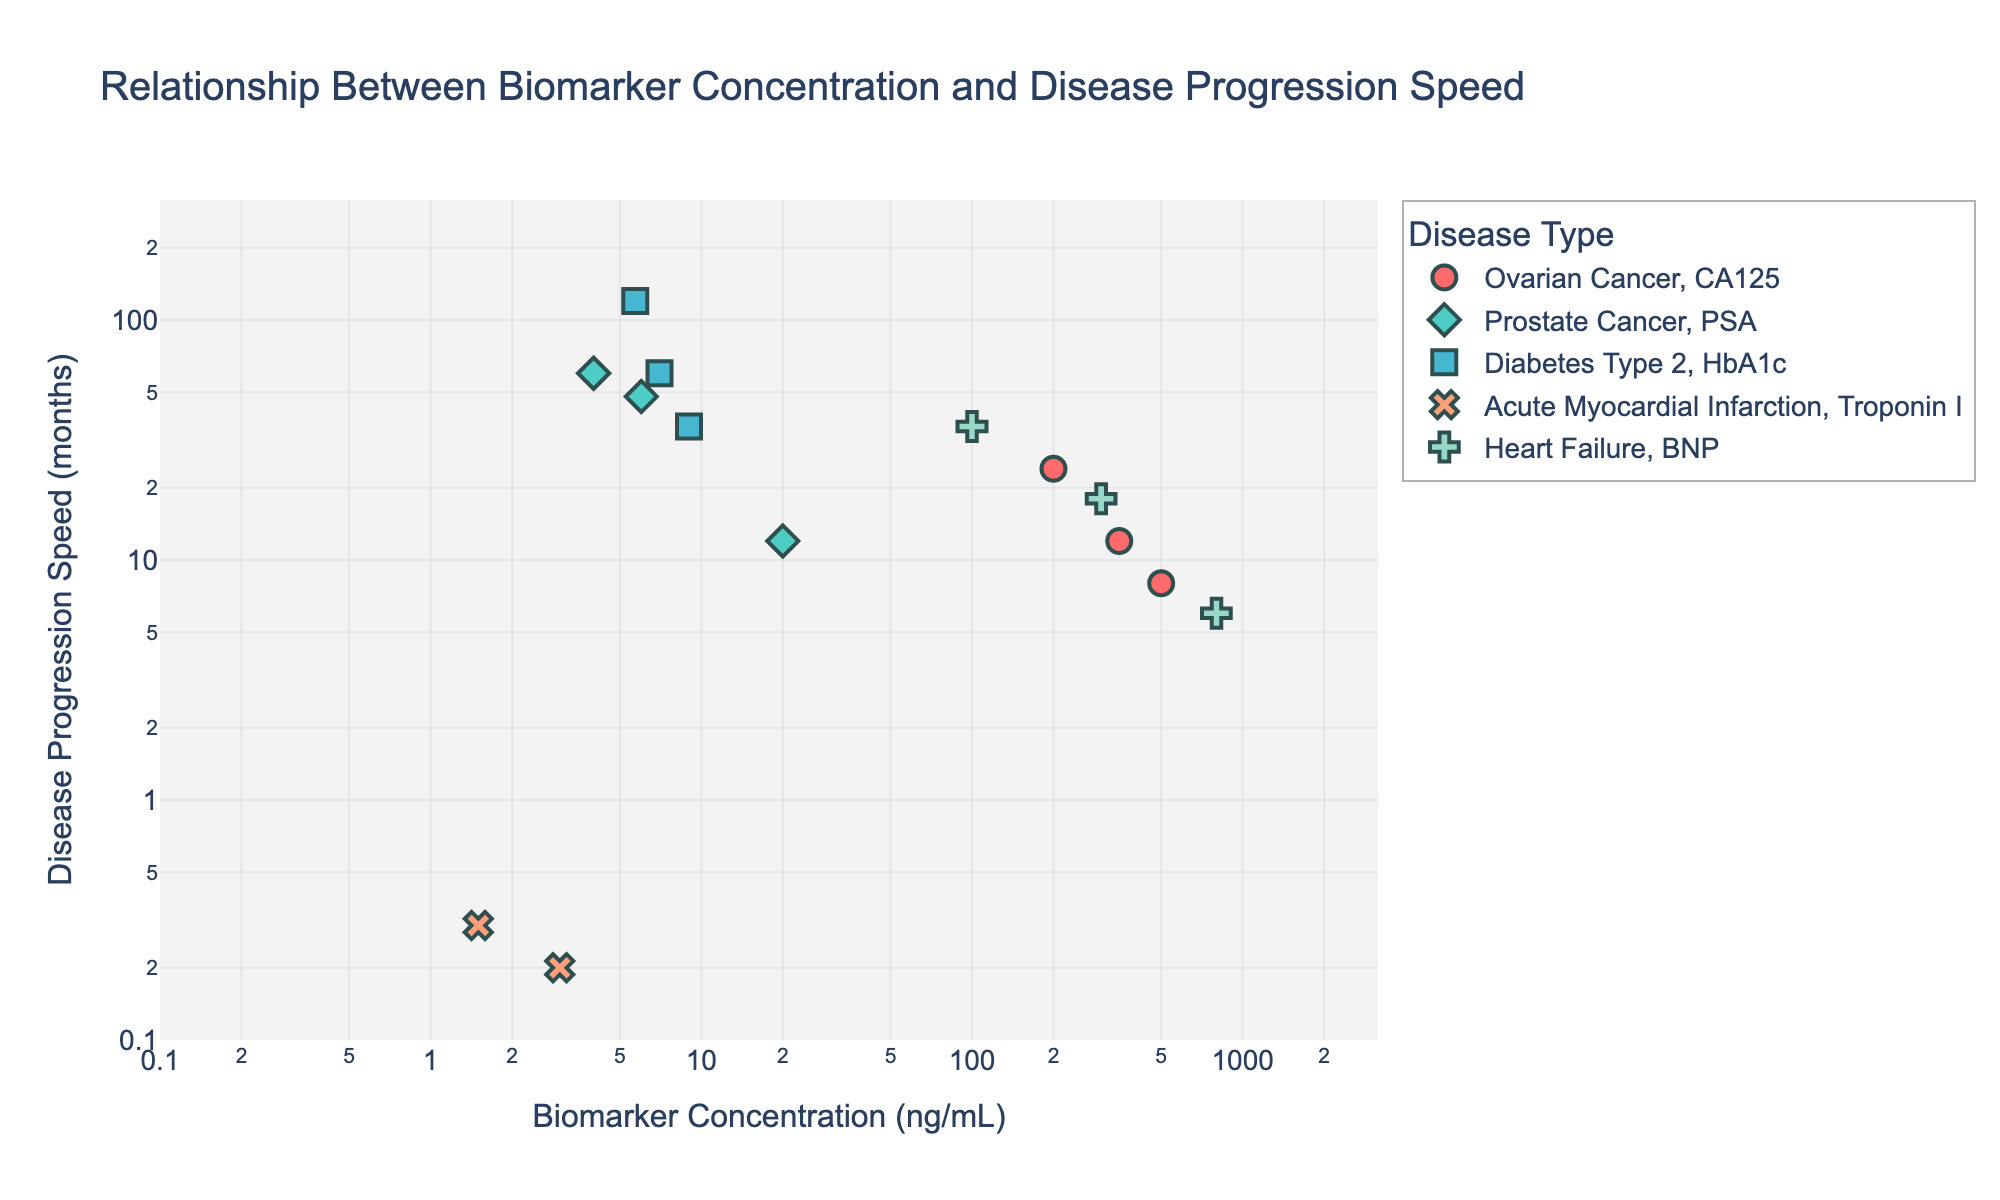What is the title of the figure? The title is displayed prominently at the top of the figure, indicating the main topic.
Answer: Relationship Between Biomarker Concentration and Disease Progression Speed Which biomarker has the highest concentration in the figure? By inspecting the x-axis values with the highest numerical value, we find that CA125 for Ovarian Cancer reaches up to 500 ng/mL, which is the highest concentration.
Answer: CA125 For Diabetes Type 2, what is the progression speed when the HbA1c concentration is 7.0 ng/mL? Locate the specific data point for Diabetes Type 2 on the scatter plot where HbA1c equals 7.0 ng/mL and read the y-axis value.
Answer: 60 months How many total data points are there for Acute Myocardial Infarction? Identify the markers associated with Acute Myocardial Infarction in the scatter plot and count each one.
Answer: 3 Which disease shows the fastest progression speed in the entire plot? Identify the point with the lowest y-axis value, which corresponds to speed in months. Troponin I for Acute Myocardial Infarction displays a minimum value of 0.2 months.
Answer: Acute Myocardial Infarction (Troponin I) What is the average progression speed of Heart Failure for the given data points? Identify the y-values for Heart Failure (36, 18, and 6 months), sum them, then divide by the number of points: (36 + 18 + 6) / 3.
Answer: 20 months Which disease has the largest spread in biomarker concentration values? Compare the range of concentrations for each disease type. Prostate Cancer, with PSA ranging from 4.0 to 20.0 ng/mL, shows the largest spread.
Answer: Prostate Cancer Between Ovarian Cancer and Prostate Cancer, which disease exhibits a faster progression speed for similar concentration ranges of their respective biomarkers? Compare the y-values for CA125 and PSA within similar x-value ranges; Ovarian Cancer (CA125) generally shows a faster disease progression.
Answer: Ovarian Cancer What is the lowest concentration of BNP associated with Heart Failure? Locate the lowest x-axis value for BNP in the scatter plot which is distinctly colored for Heart Failure.
Answer: 100 ng/mL If the concentration of HbA1c is increased from 5.7 to 9.0 ng/mL in Diabetes Type 2, how does the progression speed change? Examine the y-values for these concentrations and note the change: from 120 months to 36 months, indicating a decrease.
Answer: Decreases 